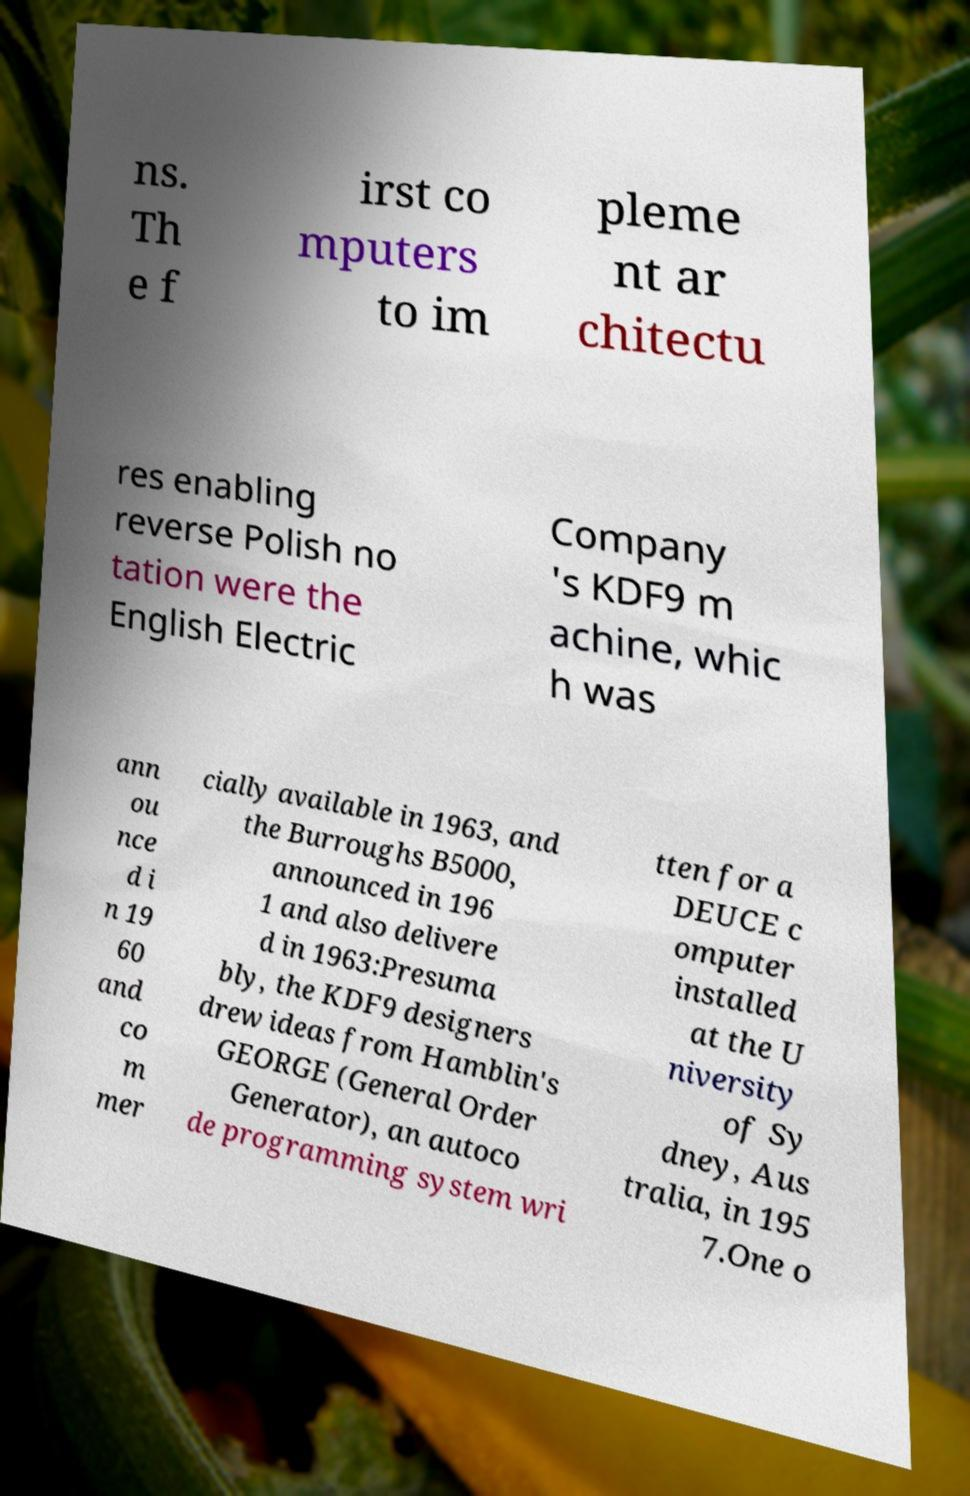What messages or text are displayed in this image? I need them in a readable, typed format. ns. Th e f irst co mputers to im pleme nt ar chitectu res enabling reverse Polish no tation were the English Electric Company 's KDF9 m achine, whic h was ann ou nce d i n 19 60 and co m mer cially available in 1963, and the Burroughs B5000, announced in 196 1 and also delivere d in 1963:Presuma bly, the KDF9 designers drew ideas from Hamblin's GEORGE (General Order Generator), an autoco de programming system wri tten for a DEUCE c omputer installed at the U niversity of Sy dney, Aus tralia, in 195 7.One o 